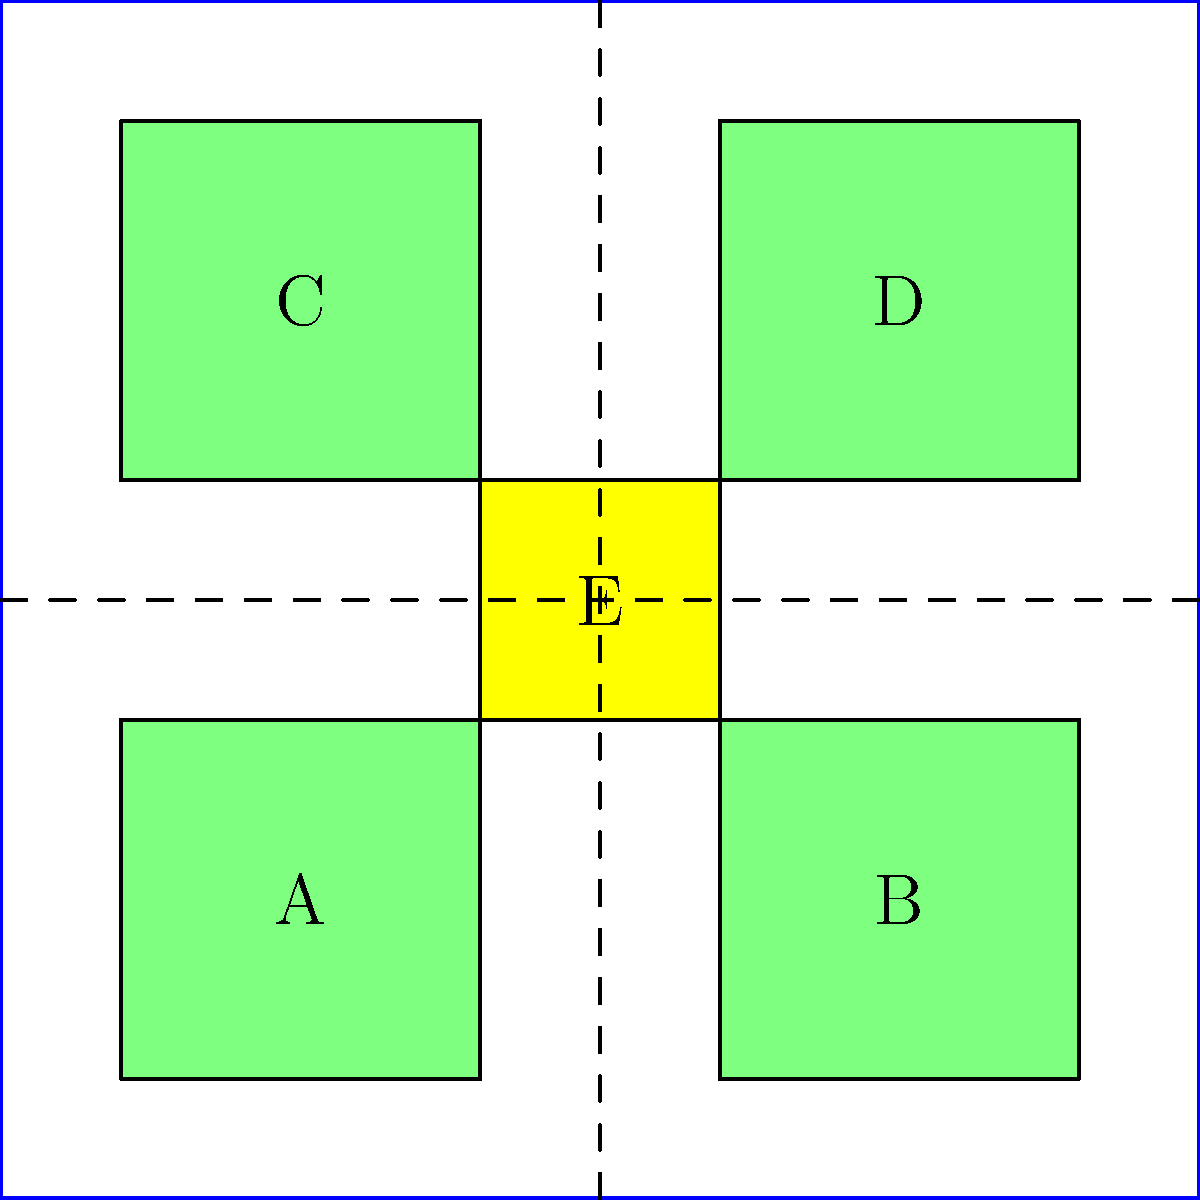In the disaster relief camp layout shown above, four shelter areas (A, B, C, D) are arranged around a central service area (E). If the camp needs to accommodate 2000 people and each shelter area can house 600 people, what is the minimum number of additional shelter areas of the same size needed to ensure all evacuees can be housed while maintaining the current spatial organization? To solve this problem, let's follow these steps:

1. Calculate the current capacity of the camp:
   - There are 4 shelter areas (A, B, C, D)
   - Each shelter area can house 600 people
   - Total current capacity = $4 \times 600 = 2400$ people

2. Determine the number of people that need accommodation:
   - The camp needs to accommodate 2000 people

3. Compare the current capacity to the required capacity:
   - Current capacity (2400) > Required capacity (2000)
   - This means the current layout can already accommodate all 2000 people

4. Calculate the excess capacity:
   - Excess capacity = Current capacity - Required capacity
   - Excess capacity = $2400 - 2000 = 400$ people

5. Determine if additional shelter areas are needed:
   - Since the current layout can accommodate all 2000 people, no additional shelter areas are required

Therefore, the minimum number of additional shelter areas needed is 0. The current spatial organization can effectively house all 2000 evacuees without any modifications.
Answer: 0 